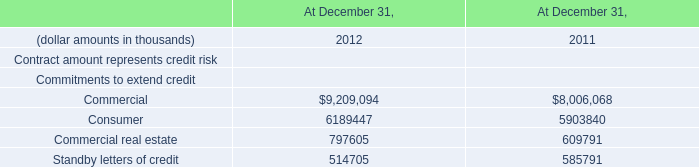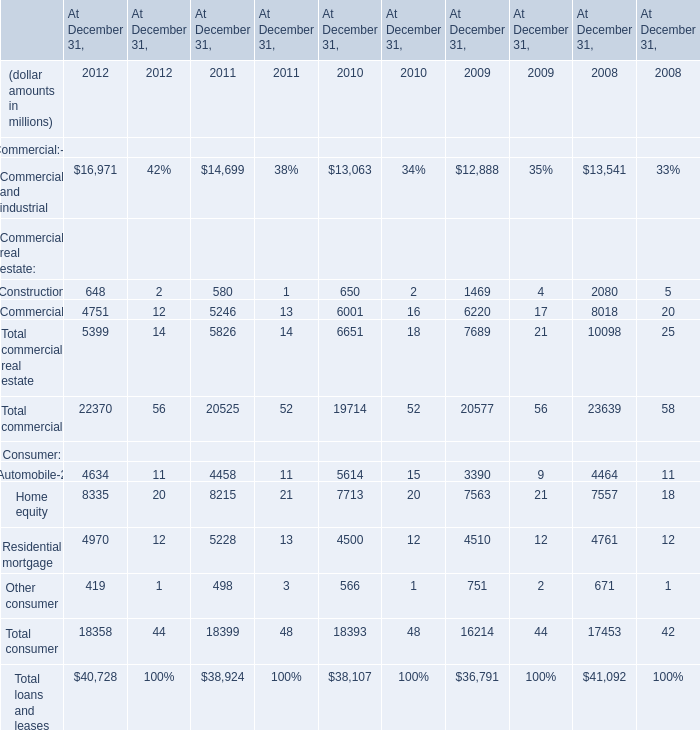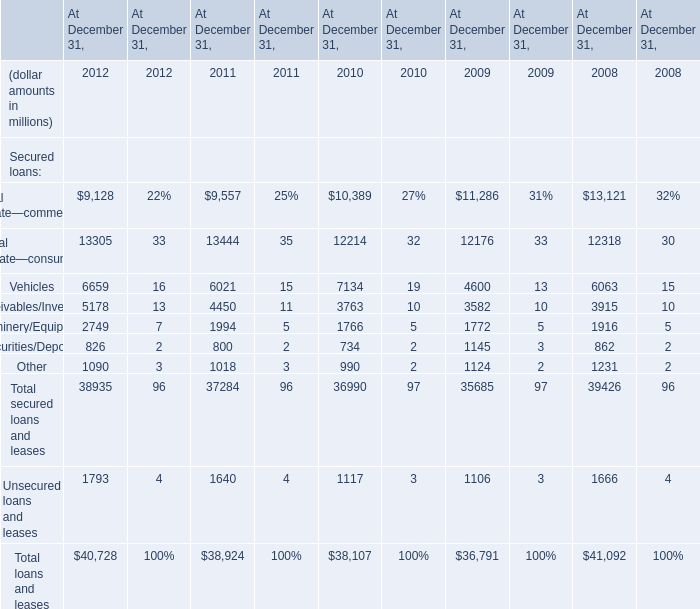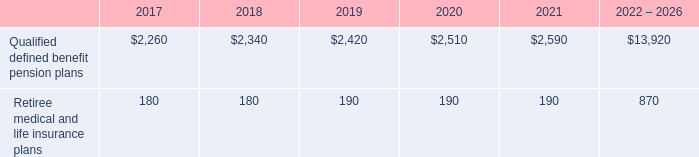what is the average price of repurchased shares during 2015? 
Computations: ((3.1 / 1000) / 15.2)
Answer: 0.0002. 